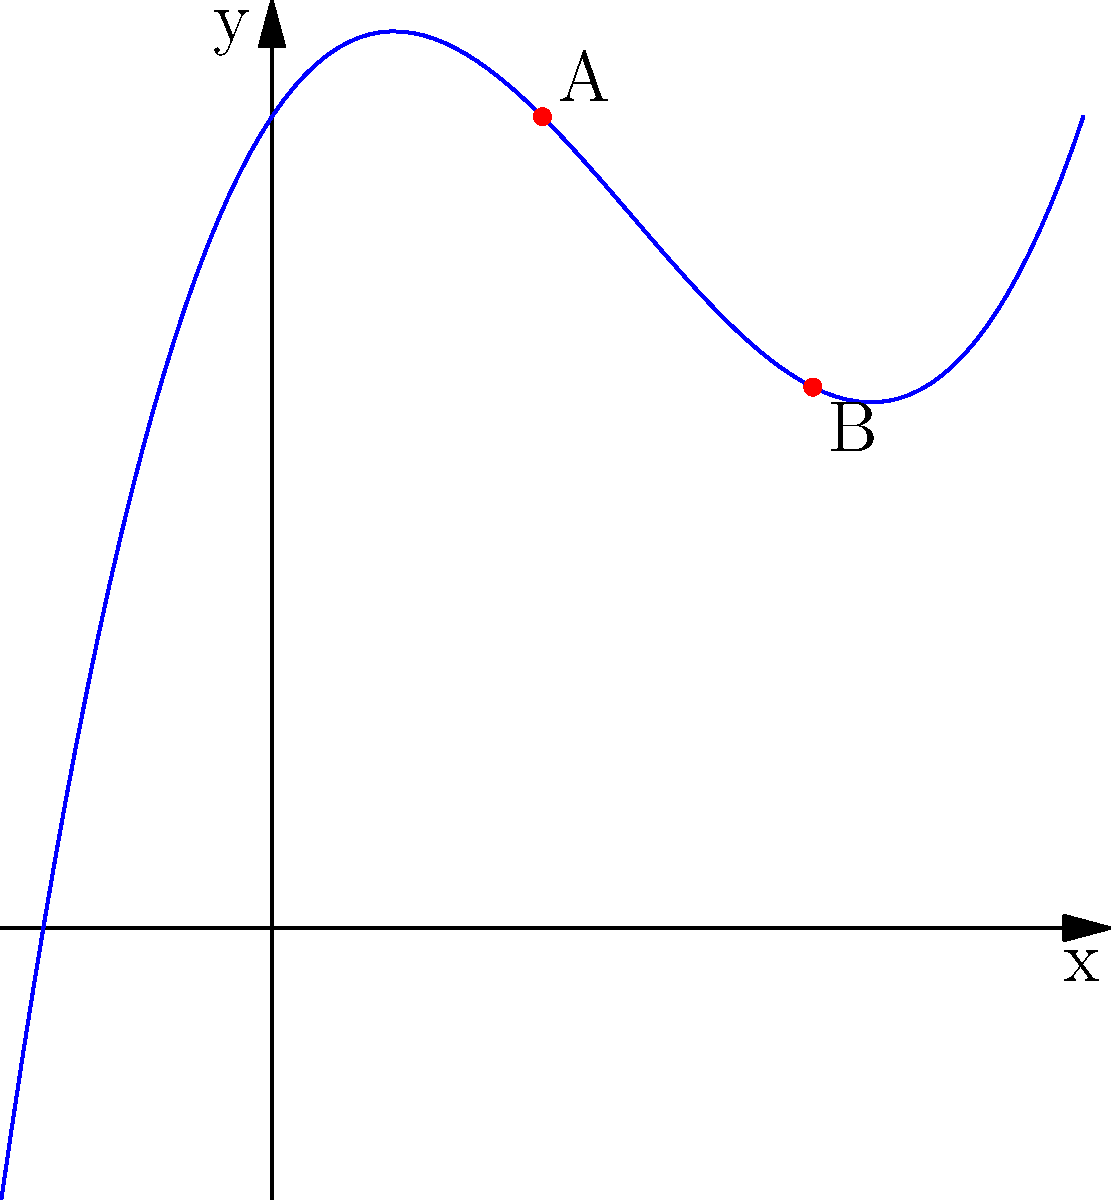You're designing a mosaic with curved edges using a polynomial function. The curve is represented by the function $f(x) = 0.5x^3 - 2x^2 + 1.5x + 3$. If you want to create two mosaic tiles that meet at points A (1, 4) and B (2, 3) on this curve, what is the average rate of change of the function between these two points? To find the average rate of change between two points, we need to follow these steps:

1. Identify the coordinates of the two points:
   Point A: (1, 4)
   Point B: (2, 3)

2. Calculate the change in y (Δy):
   Δy = y2 - y1 = 3 - 4 = -1

3. Calculate the change in x (Δx):
   Δx = x2 - x1 = 2 - 1 = 1

4. Apply the formula for average rate of change:
   Average rate of change = Δy / Δx = -1 / 1 = -1

Therefore, the average rate of change of the function between points A and B is -1.
Answer: -1 